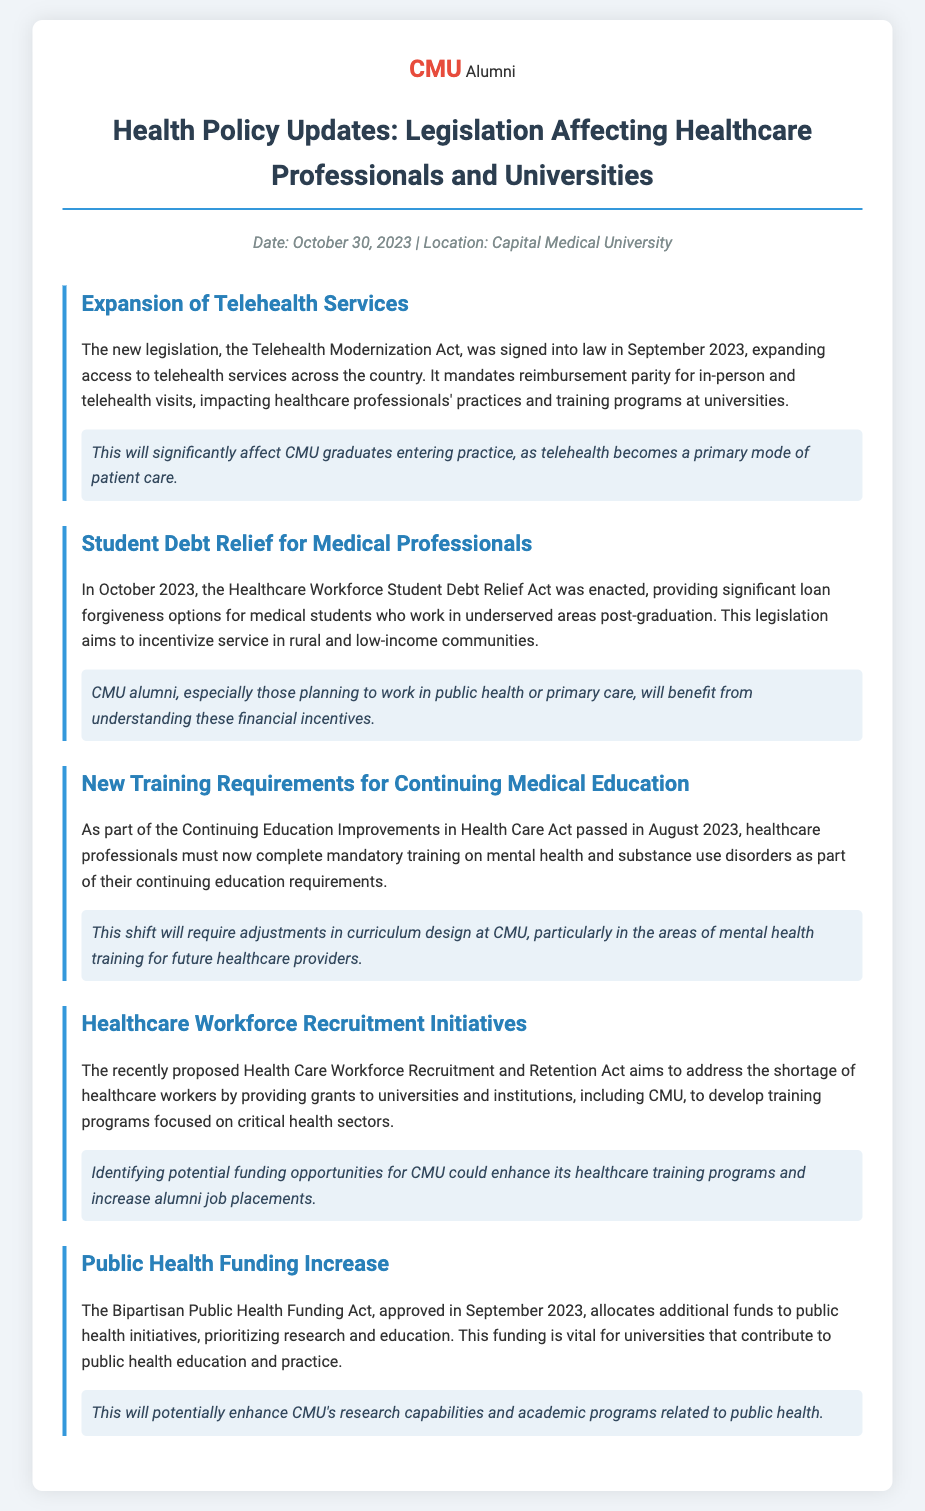What is the date of the event? The date of the event is clearly stated in the document as October 30, 2023.
Answer: October 30, 2023 What is the name of the legislation that expands telehealth services? The legislation that expands telehealth services is called the Telehealth Modernization Act.
Answer: Telehealth Modernization Act What is a primary requirement of the Continuing Education Improvements in Health Care Act? The primary requirement is mandatory training on mental health and substance use disorders for healthcare professionals.
Answer: Mandatory training on mental health and substance use disorders Which act provides loan forgiveness options for medical students? The act that provides loan forgiveness options for medical students is the Healthcare Workforce Student Debt Relief Act.
Answer: Healthcare Workforce Student Debt Relief Act What is a goal of the Health Care Workforce Recruitment and Retention Act? The goal of the act is to address the shortage of healthcare workers by providing grants for training programs.
Answer: Address the shortage of healthcare workers How will the Bipartisan Public Health Funding Act impact CMU? The act will potentially enhance CMU's research capabilities and academic programs in public health.
Answer: Enhance CMU's research capabilities What month was the new training requirement law passed? The new training requirement law was passed in August 2023.
Answer: August 2023 How does the Telehealth Modernization Act affect healthcare professionals? It mandates reimbursement parity for in-person and telehealth visits, which directly impacts healthcare professionals' practices.
Answer: Reimbursement parity for in-person and telehealth visits 